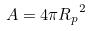<formula> <loc_0><loc_0><loc_500><loc_500>A = 4 \pi { R _ { p } } ^ { 2 }</formula> 